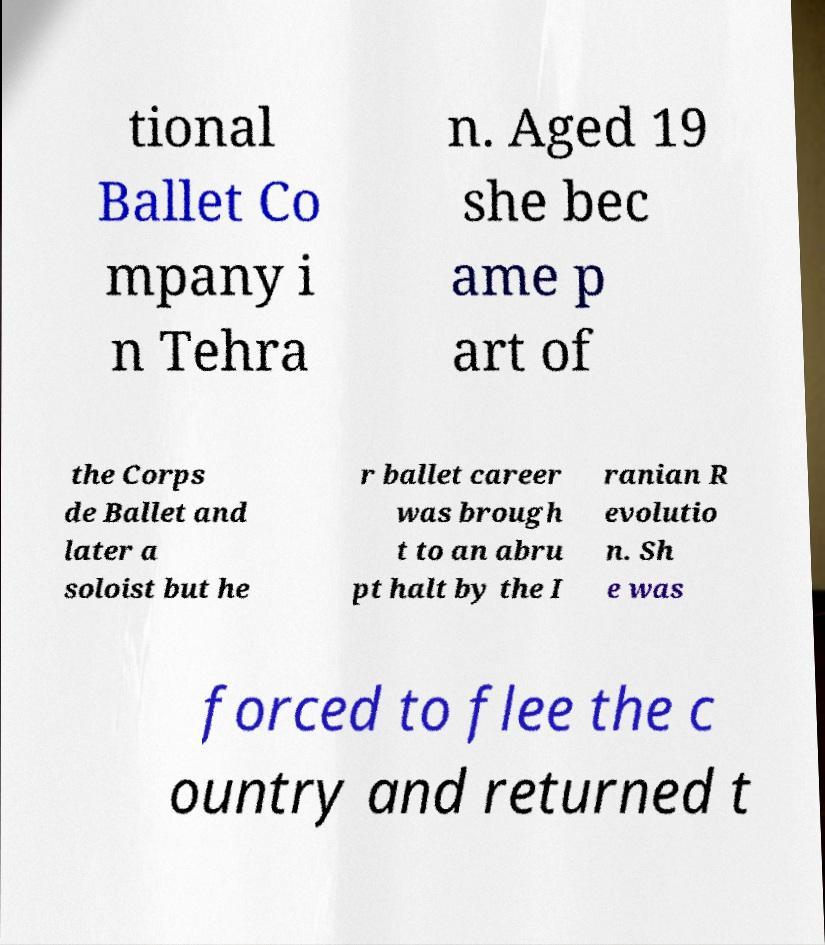For documentation purposes, I need the text within this image transcribed. Could you provide that? tional Ballet Co mpany i n Tehra n. Aged 19 she bec ame p art of the Corps de Ballet and later a soloist but he r ballet career was brough t to an abru pt halt by the I ranian R evolutio n. Sh e was forced to flee the c ountry and returned t 